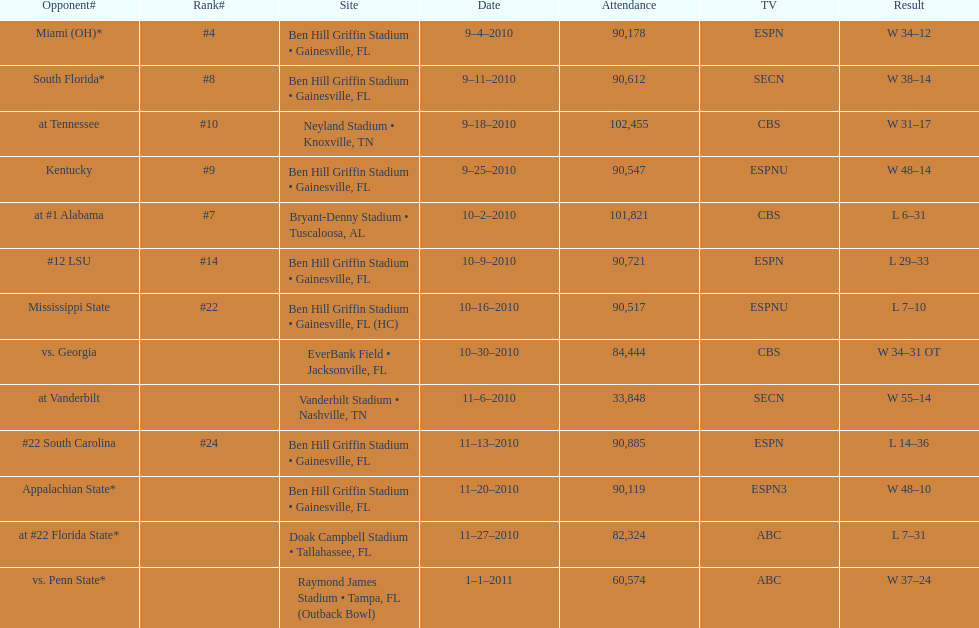How many games did the university of florida win by at least 10 points? 7. 